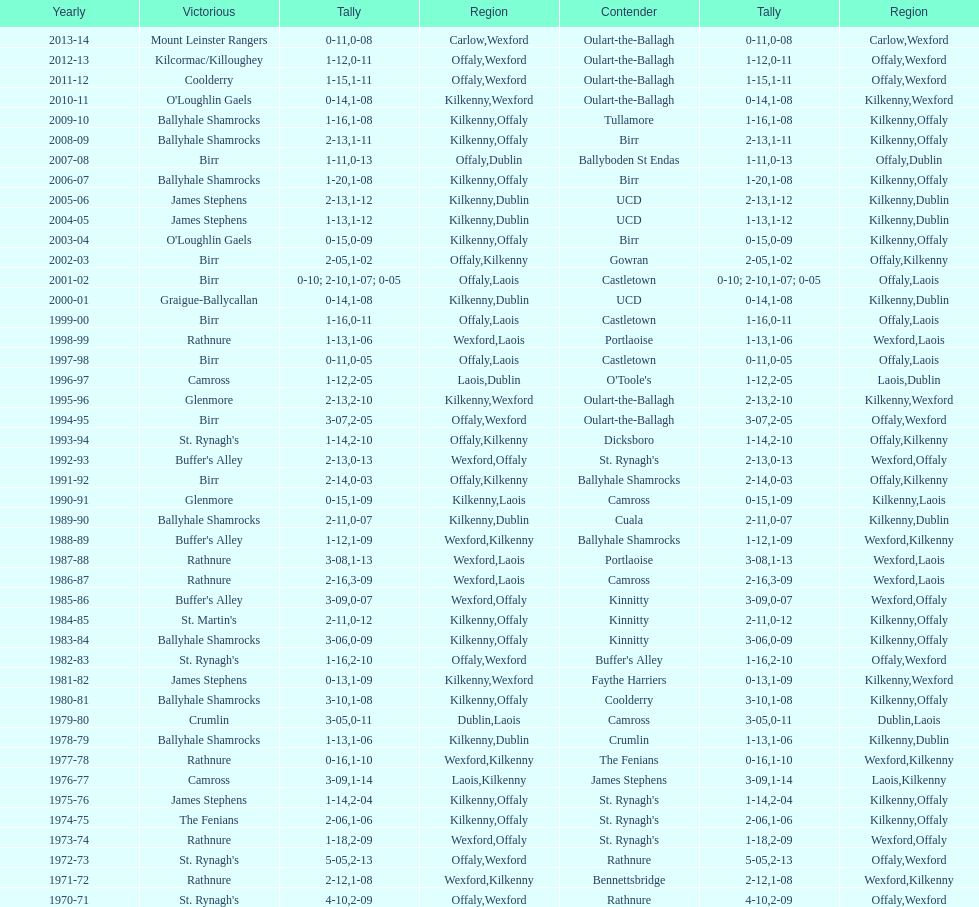Who claimed victory three years prior to that? St. Rynagh's. 